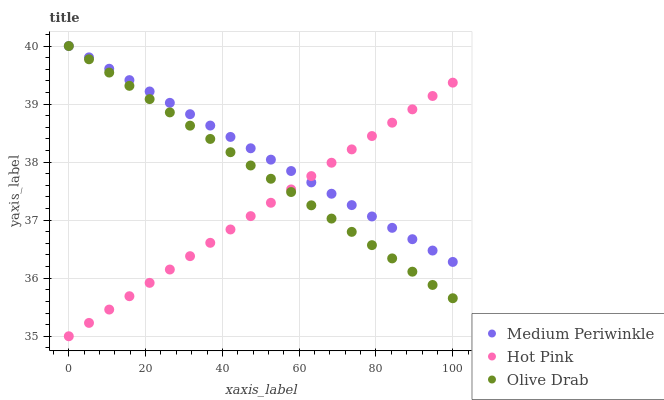Does Hot Pink have the minimum area under the curve?
Answer yes or no. Yes. Does Medium Periwinkle have the maximum area under the curve?
Answer yes or no. Yes. Does Olive Drab have the minimum area under the curve?
Answer yes or no. No. Does Olive Drab have the maximum area under the curve?
Answer yes or no. No. Is Olive Drab the smoothest?
Answer yes or no. Yes. Is Hot Pink the roughest?
Answer yes or no. Yes. Is Medium Periwinkle the smoothest?
Answer yes or no. No. Is Medium Periwinkle the roughest?
Answer yes or no. No. Does Hot Pink have the lowest value?
Answer yes or no. Yes. Does Olive Drab have the lowest value?
Answer yes or no. No. Does Olive Drab have the highest value?
Answer yes or no. Yes. Does Medium Periwinkle intersect Olive Drab?
Answer yes or no. Yes. Is Medium Periwinkle less than Olive Drab?
Answer yes or no. No. Is Medium Periwinkle greater than Olive Drab?
Answer yes or no. No. 